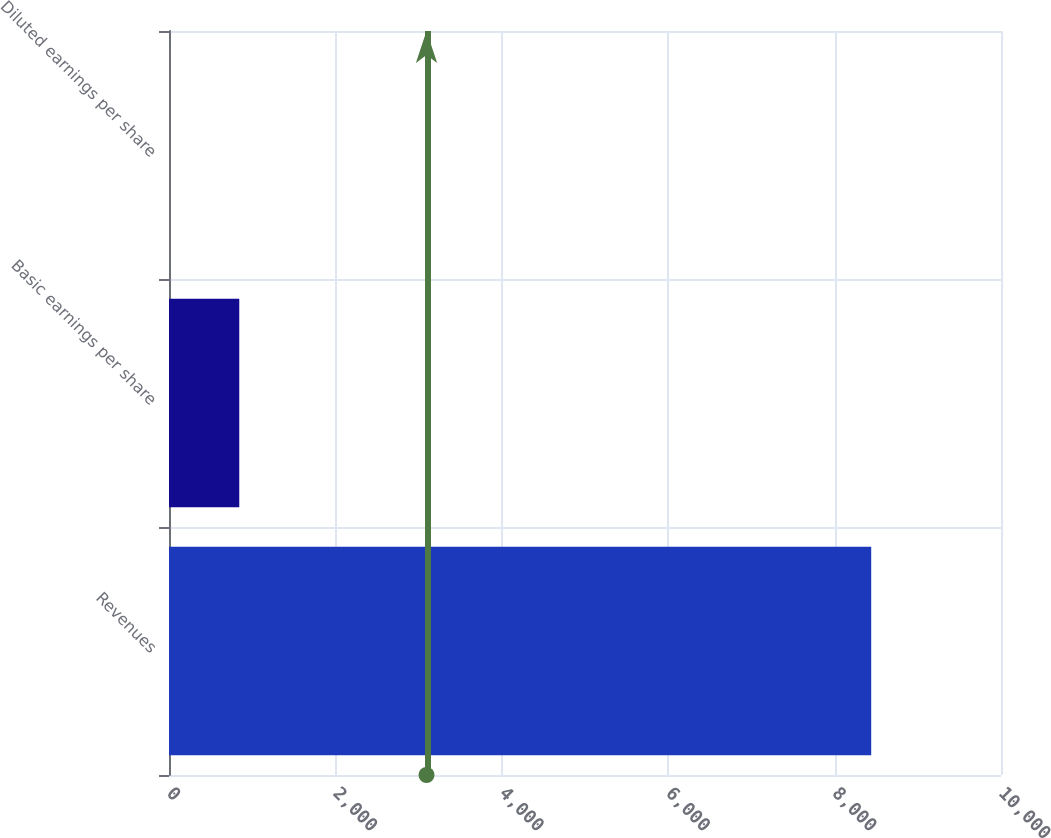<chart> <loc_0><loc_0><loc_500><loc_500><bar_chart><fcel>Revenues<fcel>Basic earnings per share<fcel>Diluted earnings per share<nl><fcel>8440<fcel>844.67<fcel>0.74<nl></chart> 